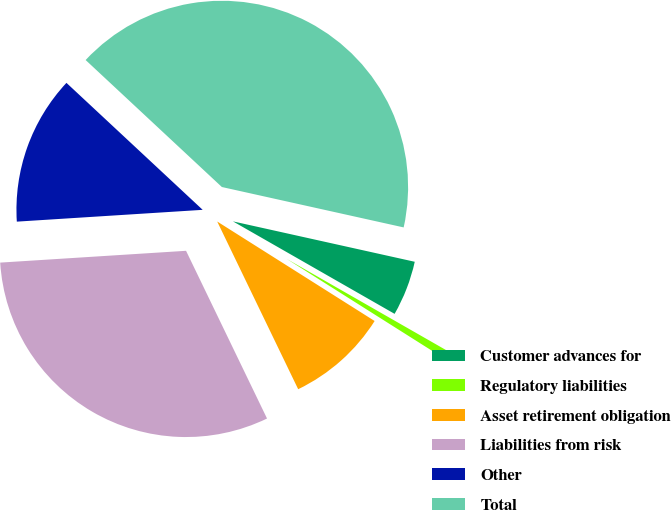Convert chart. <chart><loc_0><loc_0><loc_500><loc_500><pie_chart><fcel>Customer advances for<fcel>Regulatory liabilities<fcel>Asset retirement obligation<fcel>Liabilities from risk<fcel>Other<fcel>Total<nl><fcel>4.79%<fcel>0.7%<fcel>8.87%<fcel>31.15%<fcel>12.95%<fcel>41.54%<nl></chart> 